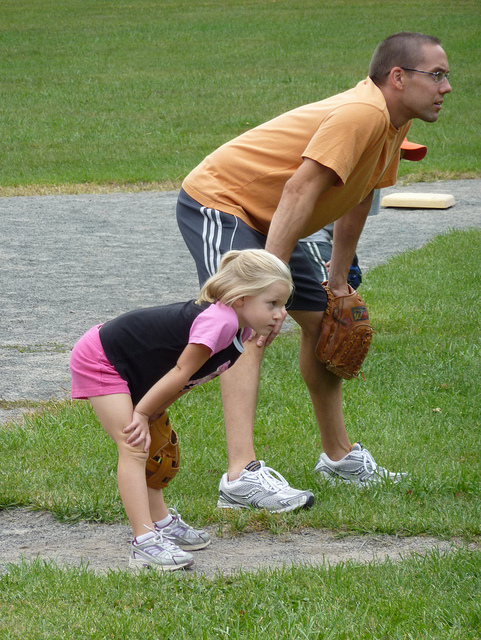How many black railroad cars are at the train station? The image does not depict a train station or any railroad cars; instead, it shows two individuals in a grassy area, one adult and one child, apparently engaged in a game of catch or a similar activity. Therefore, there are no black railroad cars to count. 